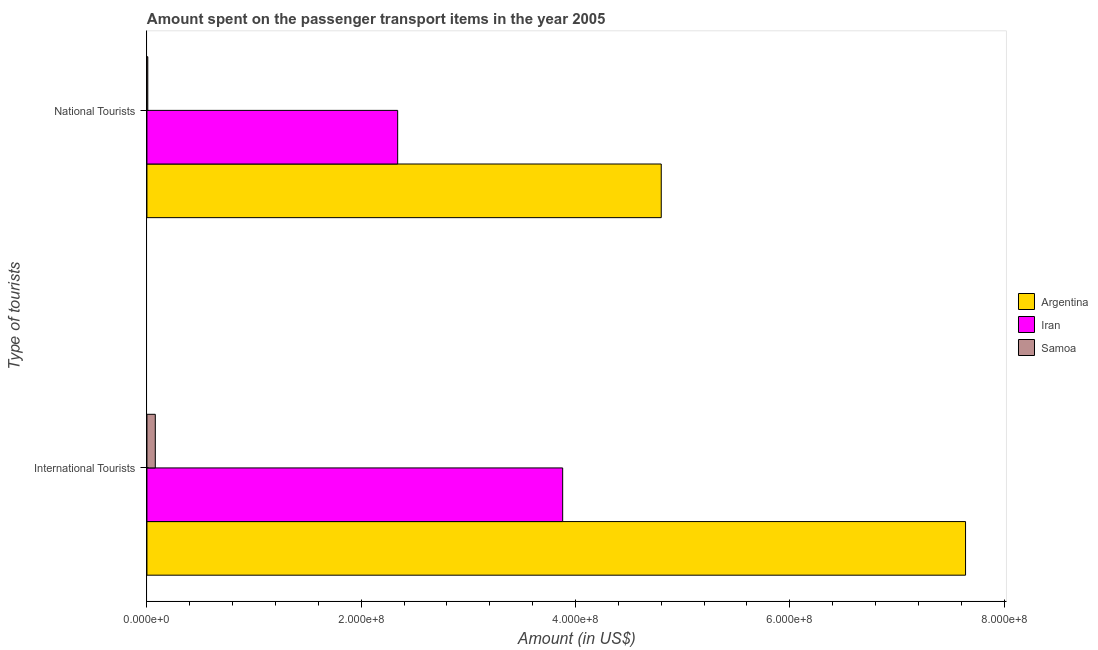How many different coloured bars are there?
Offer a very short reply. 3. Are the number of bars per tick equal to the number of legend labels?
Make the answer very short. Yes. How many bars are there on the 2nd tick from the bottom?
Give a very brief answer. 3. What is the label of the 2nd group of bars from the top?
Give a very brief answer. International Tourists. What is the amount spent on transport items of national tourists in Argentina?
Your response must be concise. 4.80e+08. Across all countries, what is the maximum amount spent on transport items of national tourists?
Give a very brief answer. 4.80e+08. Across all countries, what is the minimum amount spent on transport items of national tourists?
Offer a very short reply. 8.00e+05. In which country was the amount spent on transport items of international tourists minimum?
Provide a short and direct response. Samoa. What is the total amount spent on transport items of international tourists in the graph?
Your answer should be very brief. 1.16e+09. What is the difference between the amount spent on transport items of national tourists in Argentina and that in Samoa?
Keep it short and to the point. 4.79e+08. What is the difference between the amount spent on transport items of international tourists in Iran and the amount spent on transport items of national tourists in Argentina?
Your answer should be compact. -9.20e+07. What is the average amount spent on transport items of international tourists per country?
Provide a succinct answer. 3.87e+08. What is the difference between the amount spent on transport items of international tourists and amount spent on transport items of national tourists in Iran?
Your answer should be very brief. 1.54e+08. What is the ratio of the amount spent on transport items of international tourists in Iran to that in Argentina?
Keep it short and to the point. 0.51. Is the amount spent on transport items of national tourists in Iran less than that in Samoa?
Ensure brevity in your answer.  No. What does the 1st bar from the bottom in National Tourists represents?
Your answer should be compact. Argentina. How many bars are there?
Make the answer very short. 6. What is the difference between two consecutive major ticks on the X-axis?
Ensure brevity in your answer.  2.00e+08. Does the graph contain any zero values?
Provide a short and direct response. No. Does the graph contain grids?
Your answer should be very brief. No. Where does the legend appear in the graph?
Offer a very short reply. Center right. How many legend labels are there?
Give a very brief answer. 3. How are the legend labels stacked?
Keep it short and to the point. Vertical. What is the title of the graph?
Your response must be concise. Amount spent on the passenger transport items in the year 2005. Does "Mauritania" appear as one of the legend labels in the graph?
Provide a succinct answer. No. What is the label or title of the X-axis?
Offer a very short reply. Amount (in US$). What is the label or title of the Y-axis?
Your response must be concise. Type of tourists. What is the Amount (in US$) in Argentina in International Tourists?
Provide a short and direct response. 7.64e+08. What is the Amount (in US$) of Iran in International Tourists?
Give a very brief answer. 3.88e+08. What is the Amount (in US$) in Samoa in International Tourists?
Provide a short and direct response. 7.80e+06. What is the Amount (in US$) of Argentina in National Tourists?
Offer a terse response. 4.80e+08. What is the Amount (in US$) in Iran in National Tourists?
Your answer should be compact. 2.34e+08. What is the Amount (in US$) of Samoa in National Tourists?
Make the answer very short. 8.00e+05. Across all Type of tourists, what is the maximum Amount (in US$) of Argentina?
Offer a very short reply. 7.64e+08. Across all Type of tourists, what is the maximum Amount (in US$) in Iran?
Provide a succinct answer. 3.88e+08. Across all Type of tourists, what is the maximum Amount (in US$) in Samoa?
Provide a short and direct response. 7.80e+06. Across all Type of tourists, what is the minimum Amount (in US$) of Argentina?
Your answer should be very brief. 4.80e+08. Across all Type of tourists, what is the minimum Amount (in US$) in Iran?
Your response must be concise. 2.34e+08. What is the total Amount (in US$) in Argentina in the graph?
Make the answer very short. 1.24e+09. What is the total Amount (in US$) of Iran in the graph?
Make the answer very short. 6.22e+08. What is the total Amount (in US$) of Samoa in the graph?
Give a very brief answer. 8.60e+06. What is the difference between the Amount (in US$) in Argentina in International Tourists and that in National Tourists?
Provide a succinct answer. 2.84e+08. What is the difference between the Amount (in US$) of Iran in International Tourists and that in National Tourists?
Keep it short and to the point. 1.54e+08. What is the difference between the Amount (in US$) in Argentina in International Tourists and the Amount (in US$) in Iran in National Tourists?
Keep it short and to the point. 5.30e+08. What is the difference between the Amount (in US$) of Argentina in International Tourists and the Amount (in US$) of Samoa in National Tourists?
Offer a very short reply. 7.63e+08. What is the difference between the Amount (in US$) in Iran in International Tourists and the Amount (in US$) in Samoa in National Tourists?
Keep it short and to the point. 3.87e+08. What is the average Amount (in US$) of Argentina per Type of tourists?
Ensure brevity in your answer.  6.22e+08. What is the average Amount (in US$) of Iran per Type of tourists?
Make the answer very short. 3.11e+08. What is the average Amount (in US$) in Samoa per Type of tourists?
Your answer should be very brief. 4.30e+06. What is the difference between the Amount (in US$) in Argentina and Amount (in US$) in Iran in International Tourists?
Offer a terse response. 3.76e+08. What is the difference between the Amount (in US$) in Argentina and Amount (in US$) in Samoa in International Tourists?
Keep it short and to the point. 7.56e+08. What is the difference between the Amount (in US$) in Iran and Amount (in US$) in Samoa in International Tourists?
Offer a very short reply. 3.80e+08. What is the difference between the Amount (in US$) of Argentina and Amount (in US$) of Iran in National Tourists?
Provide a succinct answer. 2.46e+08. What is the difference between the Amount (in US$) in Argentina and Amount (in US$) in Samoa in National Tourists?
Offer a very short reply. 4.79e+08. What is the difference between the Amount (in US$) in Iran and Amount (in US$) in Samoa in National Tourists?
Your answer should be compact. 2.33e+08. What is the ratio of the Amount (in US$) of Argentina in International Tourists to that in National Tourists?
Keep it short and to the point. 1.59. What is the ratio of the Amount (in US$) of Iran in International Tourists to that in National Tourists?
Your answer should be compact. 1.66. What is the ratio of the Amount (in US$) in Samoa in International Tourists to that in National Tourists?
Offer a terse response. 9.75. What is the difference between the highest and the second highest Amount (in US$) of Argentina?
Your response must be concise. 2.84e+08. What is the difference between the highest and the second highest Amount (in US$) of Iran?
Give a very brief answer. 1.54e+08. What is the difference between the highest and the second highest Amount (in US$) of Samoa?
Ensure brevity in your answer.  7.00e+06. What is the difference between the highest and the lowest Amount (in US$) in Argentina?
Make the answer very short. 2.84e+08. What is the difference between the highest and the lowest Amount (in US$) in Iran?
Provide a short and direct response. 1.54e+08. 